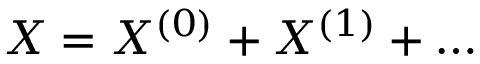<formula> <loc_0><loc_0><loc_500><loc_500>X = X ^ { ( 0 ) } + X ^ { ( 1 ) } + \dots</formula> 